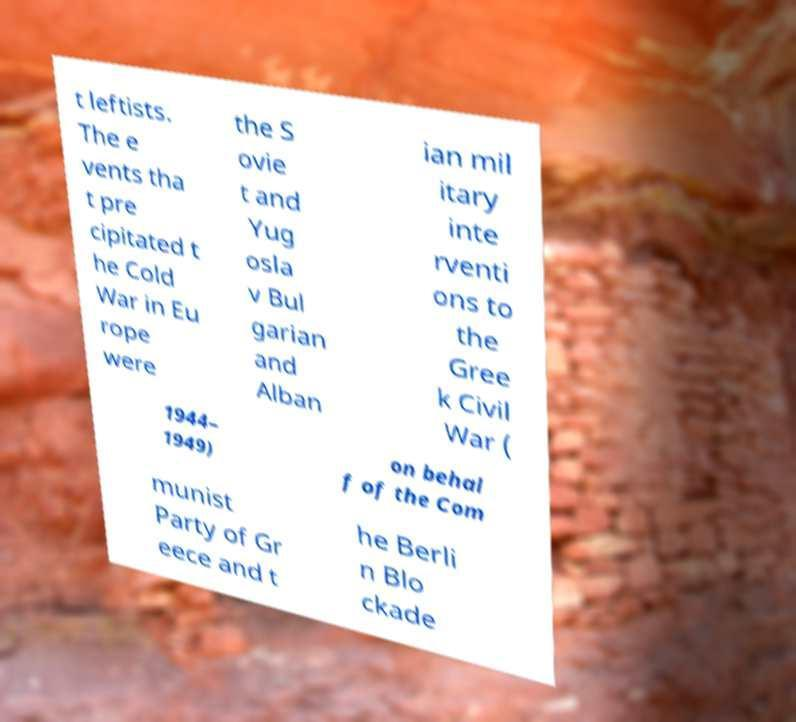Can you accurately transcribe the text from the provided image for me? t leftists. The e vents tha t pre cipitated t he Cold War in Eu rope were the S ovie t and Yug osla v Bul garian and Alban ian mil itary inte rventi ons to the Gree k Civil War ( 1944– 1949) on behal f of the Com munist Party of Gr eece and t he Berli n Blo ckade 